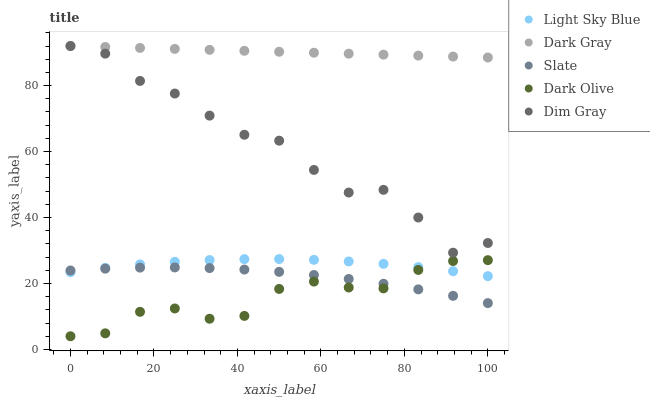Does Dark Olive have the minimum area under the curve?
Answer yes or no. Yes. Does Dark Gray have the maximum area under the curve?
Answer yes or no. Yes. Does Slate have the minimum area under the curve?
Answer yes or no. No. Does Slate have the maximum area under the curve?
Answer yes or no. No. Is Dark Gray the smoothest?
Answer yes or no. Yes. Is Dim Gray the roughest?
Answer yes or no. Yes. Is Slate the smoothest?
Answer yes or no. No. Is Slate the roughest?
Answer yes or no. No. Does Dark Olive have the lowest value?
Answer yes or no. Yes. Does Slate have the lowest value?
Answer yes or no. No. Does Dim Gray have the highest value?
Answer yes or no. Yes. Does Light Sky Blue have the highest value?
Answer yes or no. No. Is Slate less than Dim Gray?
Answer yes or no. Yes. Is Dark Gray greater than Slate?
Answer yes or no. Yes. Does Dark Olive intersect Slate?
Answer yes or no. Yes. Is Dark Olive less than Slate?
Answer yes or no. No. Is Dark Olive greater than Slate?
Answer yes or no. No. Does Slate intersect Dim Gray?
Answer yes or no. No. 